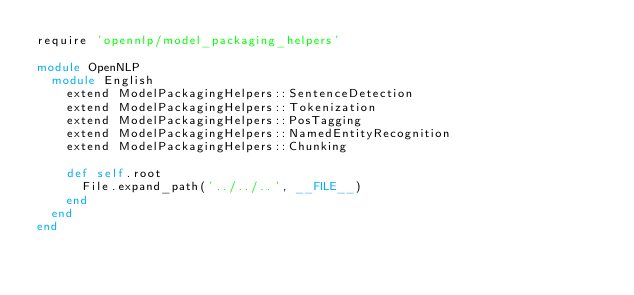Convert code to text. <code><loc_0><loc_0><loc_500><loc_500><_Ruby_>require 'opennlp/model_packaging_helpers'

module OpenNLP
  module English
    extend ModelPackagingHelpers::SentenceDetection
    extend ModelPackagingHelpers::Tokenization
    extend ModelPackagingHelpers::PosTagging
    extend ModelPackagingHelpers::NamedEntityRecognition
    extend ModelPackagingHelpers::Chunking

    def self.root
      File.expand_path('../../..', __FILE__)
    end
  end
end
</code> 